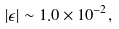<formula> <loc_0><loc_0><loc_500><loc_500>| \epsilon | \sim 1 . 0 \times 1 0 ^ { - 2 } ,</formula> 